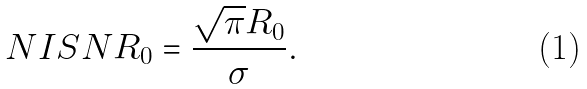Convert formula to latex. <formula><loc_0><loc_0><loc_500><loc_500>N I S N R _ { 0 } = \frac { \sqrt { \pi } R _ { 0 } } { \sigma } .</formula> 